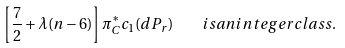Convert formula to latex. <formula><loc_0><loc_0><loc_500><loc_500>\left [ \frac { 7 } { 2 } + \lambda ( n - 6 ) \right ] \pi ^ { * } _ { C } c _ { 1 } ( d P _ { r } ) \quad i s a n i n t e g e r c l a s s .</formula> 